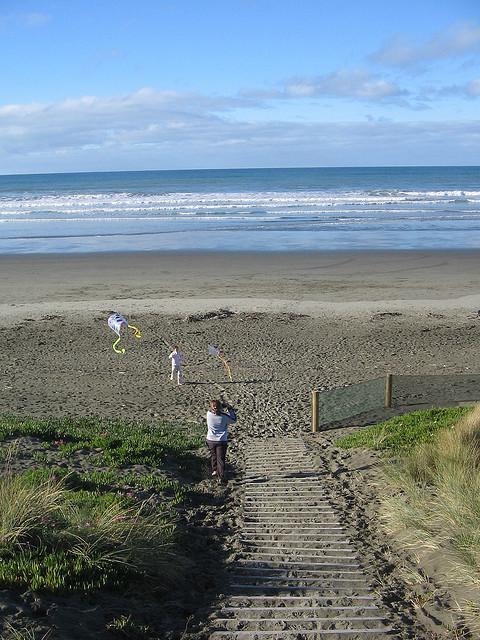What are the people doing?
Be succinct. Flying kites. How did these people get on the beach?
Be succinct. Stairs. How many kites are there in this picture?
Concise answer only. 2. 